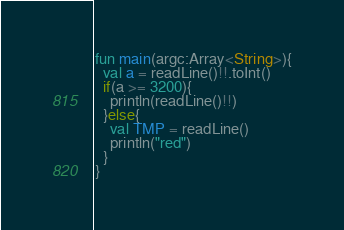Convert code to text. <code><loc_0><loc_0><loc_500><loc_500><_Kotlin_>fun main(argc:Array<String>){
  val a = readLine()!!.toInt()
  if(a >= 3200){
    println(readLine()!!)
  }else{
    val TMP = readLine()
    println("red")
  }
}</code> 